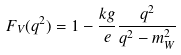Convert formula to latex. <formula><loc_0><loc_0><loc_500><loc_500>F _ { V } ( q ^ { 2 } ) = 1 - \frac { k g } { e } \frac { q ^ { 2 } } { q ^ { 2 } - m _ { W } ^ { 2 } }</formula> 